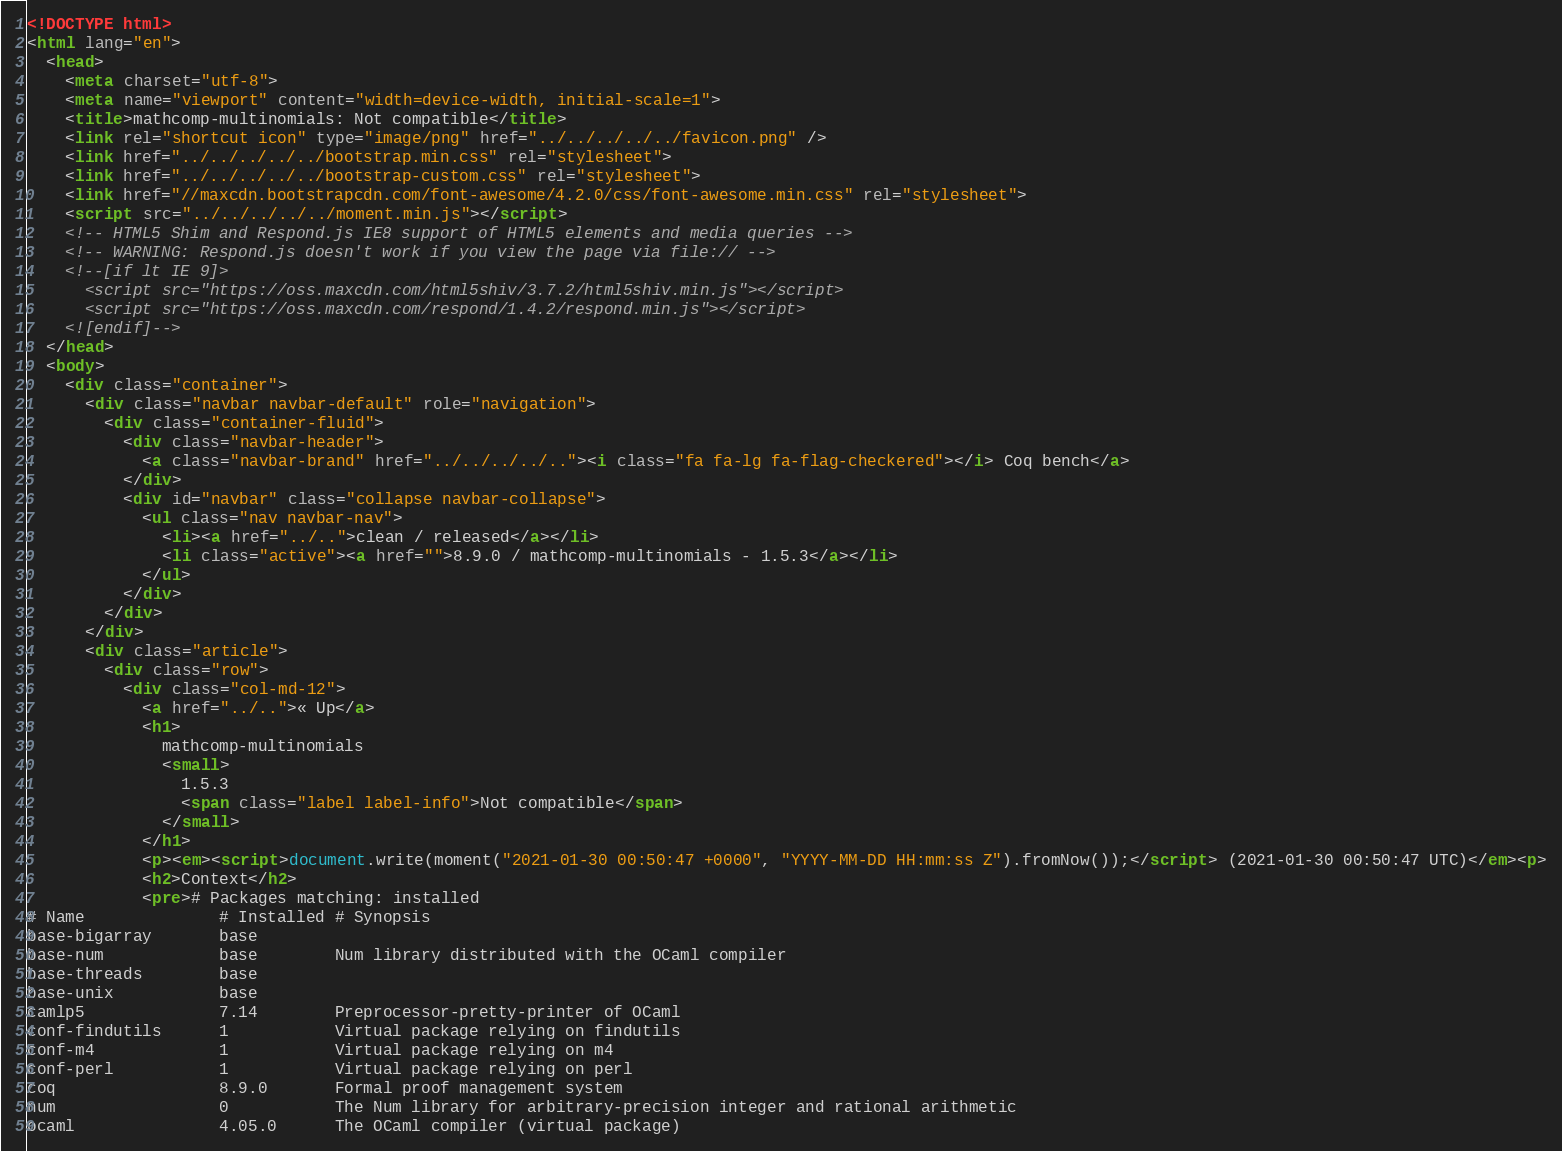<code> <loc_0><loc_0><loc_500><loc_500><_HTML_><!DOCTYPE html>
<html lang="en">
  <head>
    <meta charset="utf-8">
    <meta name="viewport" content="width=device-width, initial-scale=1">
    <title>mathcomp-multinomials: Not compatible</title>
    <link rel="shortcut icon" type="image/png" href="../../../../../favicon.png" />
    <link href="../../../../../bootstrap.min.css" rel="stylesheet">
    <link href="../../../../../bootstrap-custom.css" rel="stylesheet">
    <link href="//maxcdn.bootstrapcdn.com/font-awesome/4.2.0/css/font-awesome.min.css" rel="stylesheet">
    <script src="../../../../../moment.min.js"></script>
    <!-- HTML5 Shim and Respond.js IE8 support of HTML5 elements and media queries -->
    <!-- WARNING: Respond.js doesn't work if you view the page via file:// -->
    <!--[if lt IE 9]>
      <script src="https://oss.maxcdn.com/html5shiv/3.7.2/html5shiv.min.js"></script>
      <script src="https://oss.maxcdn.com/respond/1.4.2/respond.min.js"></script>
    <![endif]-->
  </head>
  <body>
    <div class="container">
      <div class="navbar navbar-default" role="navigation">
        <div class="container-fluid">
          <div class="navbar-header">
            <a class="navbar-brand" href="../../../../.."><i class="fa fa-lg fa-flag-checkered"></i> Coq bench</a>
          </div>
          <div id="navbar" class="collapse navbar-collapse">
            <ul class="nav navbar-nav">
              <li><a href="../..">clean / released</a></li>
              <li class="active"><a href="">8.9.0 / mathcomp-multinomials - 1.5.3</a></li>
            </ul>
          </div>
        </div>
      </div>
      <div class="article">
        <div class="row">
          <div class="col-md-12">
            <a href="../..">« Up</a>
            <h1>
              mathcomp-multinomials
              <small>
                1.5.3
                <span class="label label-info">Not compatible</span>
              </small>
            </h1>
            <p><em><script>document.write(moment("2021-01-30 00:50:47 +0000", "YYYY-MM-DD HH:mm:ss Z").fromNow());</script> (2021-01-30 00:50:47 UTC)</em><p>
            <h2>Context</h2>
            <pre># Packages matching: installed
# Name              # Installed # Synopsis
base-bigarray       base
base-num            base        Num library distributed with the OCaml compiler
base-threads        base
base-unix           base
camlp5              7.14        Preprocessor-pretty-printer of OCaml
conf-findutils      1           Virtual package relying on findutils
conf-m4             1           Virtual package relying on m4
conf-perl           1           Virtual package relying on perl
coq                 8.9.0       Formal proof management system
num                 0           The Num library for arbitrary-precision integer and rational arithmetic
ocaml               4.05.0      The OCaml compiler (virtual package)</code> 